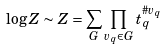<formula> <loc_0><loc_0><loc_500><loc_500>\log Z \sim Z = \sum _ { G } \prod _ { v _ { q } \in G } t _ { q } ^ { \# v _ { q } }</formula> 